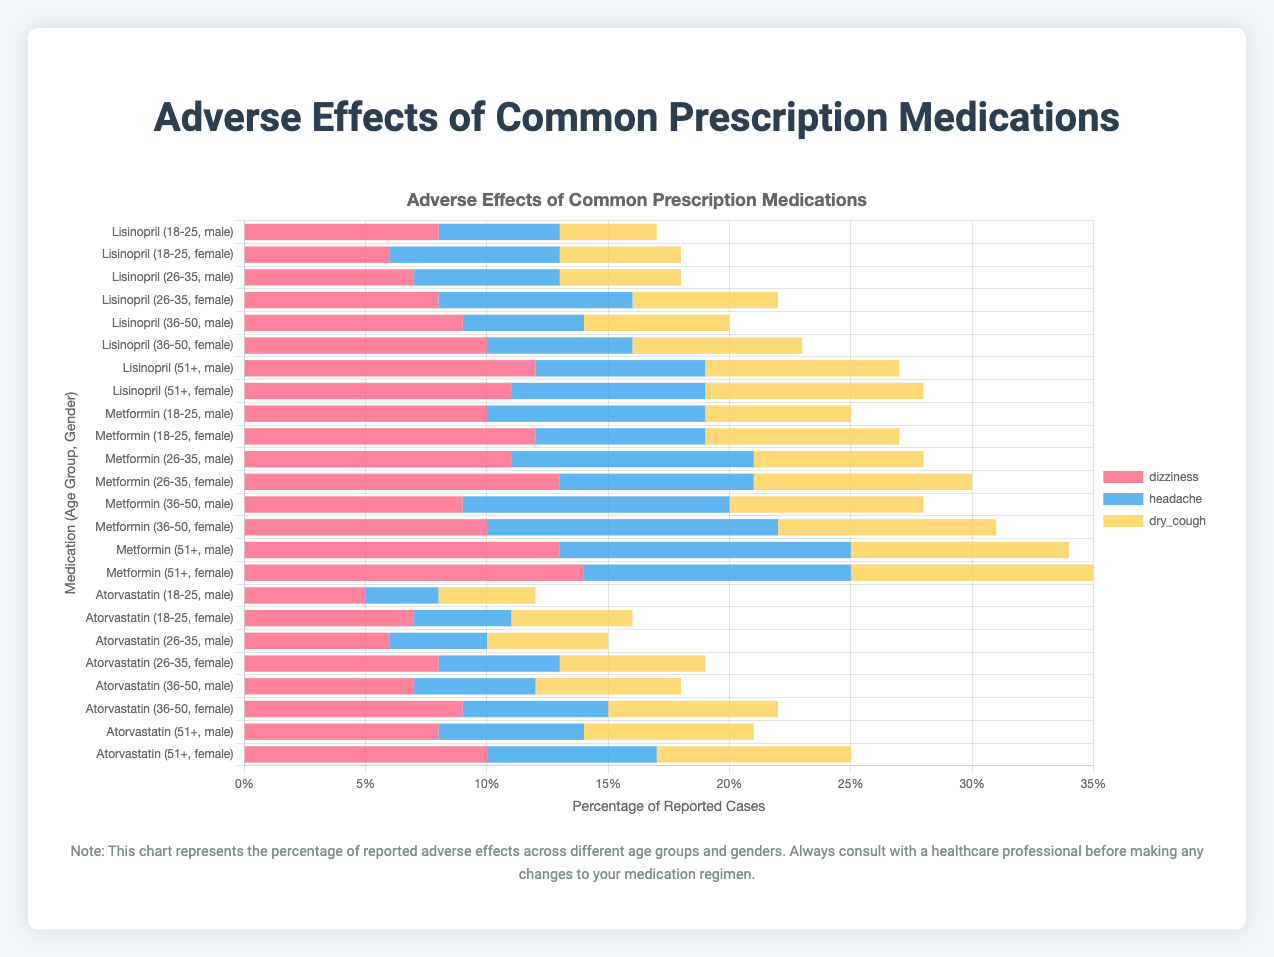What is the most common adverse effect of Lisinopril among males aged 51+? Look for the highest value among the given adverse effects for males aged 51+. Dizziness has the highest value of 12.
Answer: Dizziness Which medication causes the most muscle pain among females aged 18-25? Compare the muscle pain values for the different medications for females aged 18-25. Atorvastatin has the highest value of 7.
Answer: Atorvastatin In the 36-50 age group, which gender reports more fatigue when taking Metformin? Compare the fatigue values for both genders in the 36-50 age group for Metformin. Females have a higher value (9) compared to males (8).
Answer: Female How does the average occurrence of nausea differ between the age group 18-25 and 51+ for males taking Metformin? First, calculate the average nausea for each group by summing the values and dividing by the number of values. For 18-25: 10. For 51+: 13. The difference is 13 - 10 = 3.
Answer: 3 Which medication and demographic report the highest number of adverse effects for dry cough? Look for the highest value of dry cough across all medications and demographics. Females aged 51+ taking Lisinopril have the highest (9).
Answer: Lisinopril, Females aged 51+ What is the total number of reported dizziness cases for both gender groups in the 26-35 age group taking Lisinopril? Sum the dizziness values for both genders in the 26-35 age group for Lisinopril. Male: 7, Female: 8. Total is 7 + 8 = 15.
Answer: 15 Which age group reports the highest number of liver issue cases for males taking Atorvastatin? Look for the highest value of liver issue cases across different age groups for males taking Atorvastatin. The age group 51+ reports the highest (6).
Answer: 51+ What is the combined percentage of reported headache cases for females taking Lisinopril in all age groups? Sum the values for headache across all age groups for females taking Lisinopril. 18-25: 7, 26-35: 8, 36-50: 6, 51+: 8. Total is 7 + 8 + 6 + 8 = 29.
Answer: 29 Which adverse effect has the lowest report among females aged 51+ taking Metformin? Compare the values of adverse effects for females aged 51+ taking Metformin. Diarrhea has the lowest value (11).
Answer: Diarrhea 